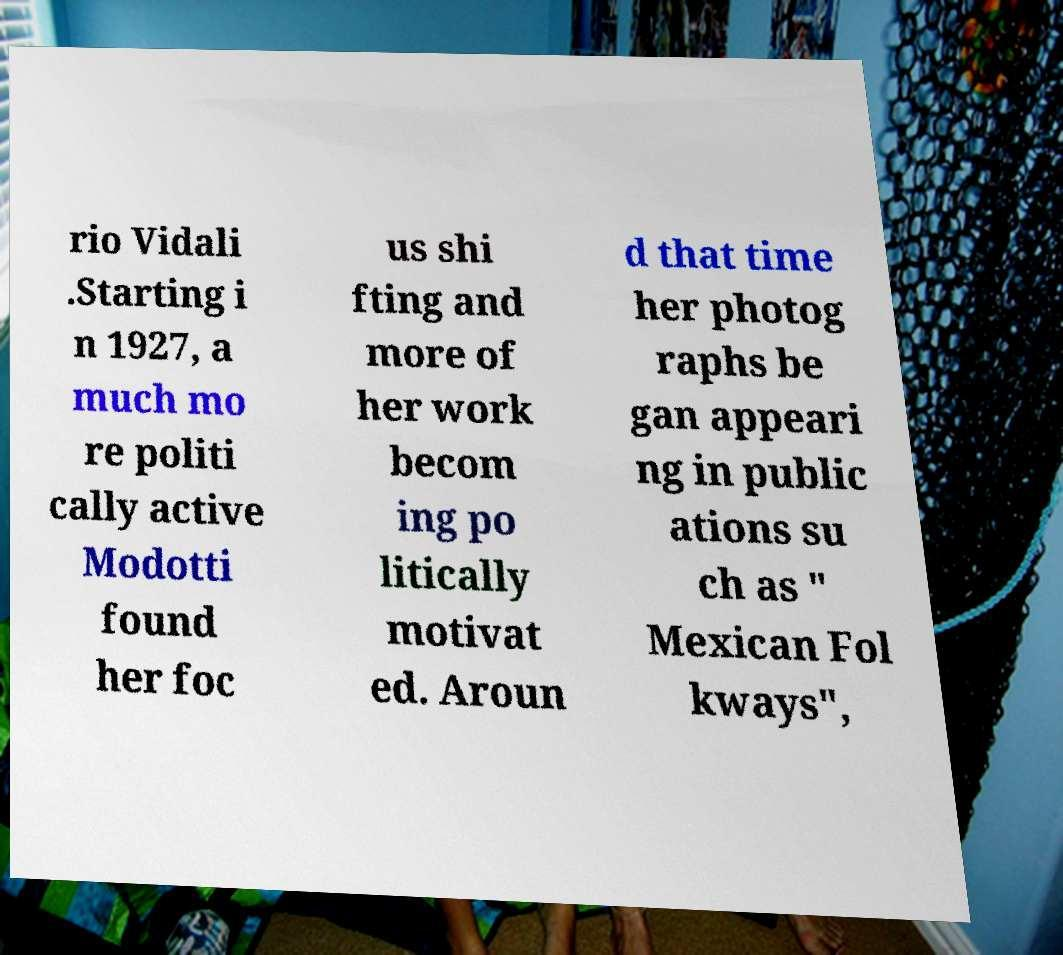Please identify and transcribe the text found in this image. rio Vidali .Starting i n 1927, a much mo re politi cally active Modotti found her foc us shi fting and more of her work becom ing po litically motivat ed. Aroun d that time her photog raphs be gan appeari ng in public ations su ch as " Mexican Fol kways", 